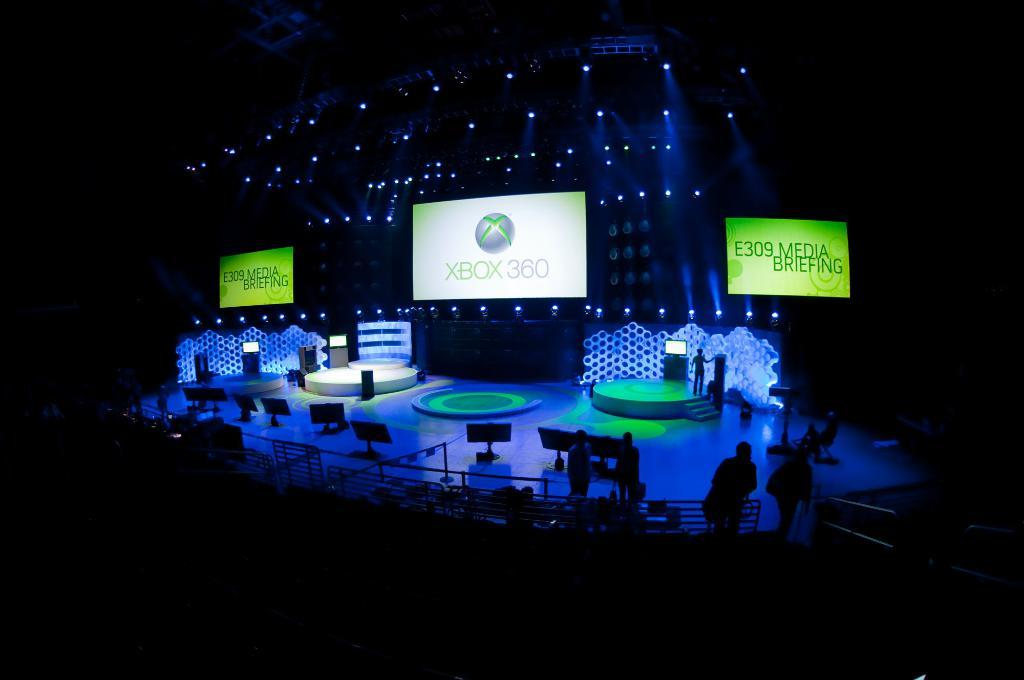What is the main setting of the image? The main setting of the image is a stadium. What can be seen in the background of the image? There are screens and lights in the background of the image. What is the weight of the flight that is visible in the image? There is no flight present in the image, so it is not possible to determine its weight. 